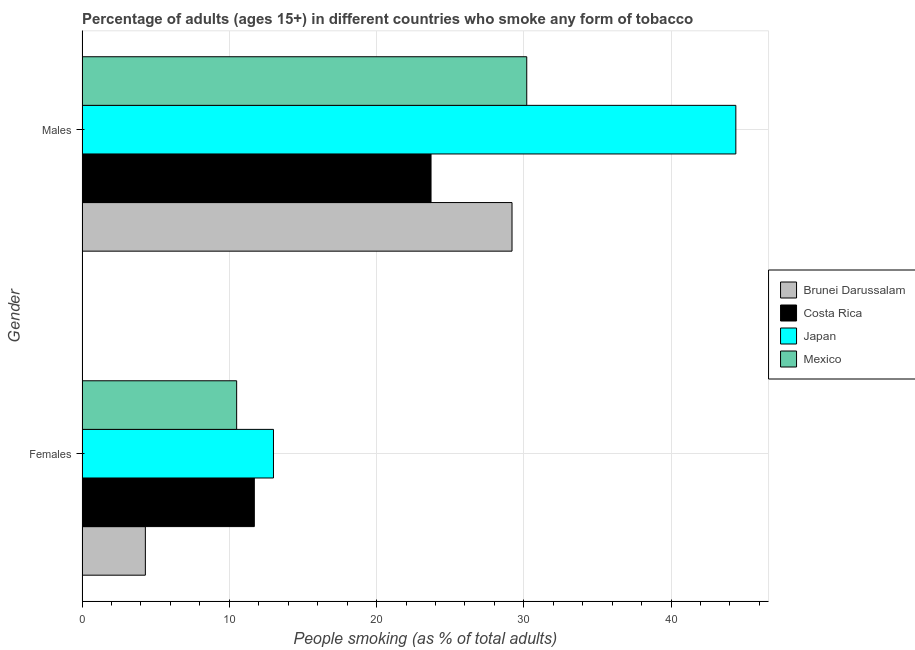How many different coloured bars are there?
Give a very brief answer. 4. Are the number of bars on each tick of the Y-axis equal?
Make the answer very short. Yes. How many bars are there on the 2nd tick from the top?
Offer a terse response. 4. What is the label of the 2nd group of bars from the top?
Your answer should be very brief. Females. Across all countries, what is the maximum percentage of males who smoke?
Provide a succinct answer. 44.4. In which country was the percentage of females who smoke minimum?
Your answer should be compact. Brunei Darussalam. What is the total percentage of females who smoke in the graph?
Offer a very short reply. 39.5. What is the difference between the percentage of females who smoke in Brunei Darussalam and the percentage of males who smoke in Mexico?
Give a very brief answer. -25.9. What is the average percentage of males who smoke per country?
Keep it short and to the point. 31.88. What is the difference between the percentage of females who smoke and percentage of males who smoke in Japan?
Provide a short and direct response. -31.4. In how many countries, is the percentage of females who smoke greater than 44 %?
Make the answer very short. 0. What is the ratio of the percentage of females who smoke in Brunei Darussalam to that in Japan?
Give a very brief answer. 0.33. In how many countries, is the percentage of males who smoke greater than the average percentage of males who smoke taken over all countries?
Give a very brief answer. 1. What does the 3rd bar from the top in Males represents?
Provide a succinct answer. Costa Rica. What does the 2nd bar from the bottom in Males represents?
Offer a terse response. Costa Rica. How many bars are there?
Offer a terse response. 8. How many countries are there in the graph?
Provide a short and direct response. 4. What is the difference between two consecutive major ticks on the X-axis?
Make the answer very short. 10. Does the graph contain grids?
Your response must be concise. Yes. Where does the legend appear in the graph?
Your answer should be compact. Center right. How are the legend labels stacked?
Provide a short and direct response. Vertical. What is the title of the graph?
Provide a short and direct response. Percentage of adults (ages 15+) in different countries who smoke any form of tobacco. What is the label or title of the X-axis?
Keep it short and to the point. People smoking (as % of total adults). What is the label or title of the Y-axis?
Make the answer very short. Gender. What is the People smoking (as % of total adults) of Brunei Darussalam in Females?
Provide a succinct answer. 4.3. What is the People smoking (as % of total adults) of Mexico in Females?
Your answer should be very brief. 10.5. What is the People smoking (as % of total adults) in Brunei Darussalam in Males?
Keep it short and to the point. 29.2. What is the People smoking (as % of total adults) in Costa Rica in Males?
Offer a very short reply. 23.7. What is the People smoking (as % of total adults) in Japan in Males?
Keep it short and to the point. 44.4. What is the People smoking (as % of total adults) of Mexico in Males?
Your response must be concise. 30.2. Across all Gender, what is the maximum People smoking (as % of total adults) of Brunei Darussalam?
Ensure brevity in your answer.  29.2. Across all Gender, what is the maximum People smoking (as % of total adults) of Costa Rica?
Offer a very short reply. 23.7. Across all Gender, what is the maximum People smoking (as % of total adults) of Japan?
Your response must be concise. 44.4. Across all Gender, what is the maximum People smoking (as % of total adults) in Mexico?
Keep it short and to the point. 30.2. Across all Gender, what is the minimum People smoking (as % of total adults) in Brunei Darussalam?
Keep it short and to the point. 4.3. What is the total People smoking (as % of total adults) of Brunei Darussalam in the graph?
Make the answer very short. 33.5. What is the total People smoking (as % of total adults) of Costa Rica in the graph?
Offer a very short reply. 35.4. What is the total People smoking (as % of total adults) of Japan in the graph?
Make the answer very short. 57.4. What is the total People smoking (as % of total adults) of Mexico in the graph?
Ensure brevity in your answer.  40.7. What is the difference between the People smoking (as % of total adults) of Brunei Darussalam in Females and that in Males?
Make the answer very short. -24.9. What is the difference between the People smoking (as % of total adults) of Japan in Females and that in Males?
Provide a succinct answer. -31.4. What is the difference between the People smoking (as % of total adults) of Mexico in Females and that in Males?
Provide a short and direct response. -19.7. What is the difference between the People smoking (as % of total adults) in Brunei Darussalam in Females and the People smoking (as % of total adults) in Costa Rica in Males?
Provide a succinct answer. -19.4. What is the difference between the People smoking (as % of total adults) in Brunei Darussalam in Females and the People smoking (as % of total adults) in Japan in Males?
Provide a succinct answer. -40.1. What is the difference between the People smoking (as % of total adults) in Brunei Darussalam in Females and the People smoking (as % of total adults) in Mexico in Males?
Keep it short and to the point. -25.9. What is the difference between the People smoking (as % of total adults) in Costa Rica in Females and the People smoking (as % of total adults) in Japan in Males?
Your response must be concise. -32.7. What is the difference between the People smoking (as % of total adults) of Costa Rica in Females and the People smoking (as % of total adults) of Mexico in Males?
Offer a very short reply. -18.5. What is the difference between the People smoking (as % of total adults) in Japan in Females and the People smoking (as % of total adults) in Mexico in Males?
Make the answer very short. -17.2. What is the average People smoking (as % of total adults) in Brunei Darussalam per Gender?
Provide a short and direct response. 16.75. What is the average People smoking (as % of total adults) of Costa Rica per Gender?
Keep it short and to the point. 17.7. What is the average People smoking (as % of total adults) of Japan per Gender?
Keep it short and to the point. 28.7. What is the average People smoking (as % of total adults) of Mexico per Gender?
Provide a succinct answer. 20.35. What is the difference between the People smoking (as % of total adults) of Brunei Darussalam and People smoking (as % of total adults) of Costa Rica in Females?
Ensure brevity in your answer.  -7.4. What is the difference between the People smoking (as % of total adults) in Japan and People smoking (as % of total adults) in Mexico in Females?
Give a very brief answer. 2.5. What is the difference between the People smoking (as % of total adults) in Brunei Darussalam and People smoking (as % of total adults) in Japan in Males?
Your response must be concise. -15.2. What is the difference between the People smoking (as % of total adults) in Costa Rica and People smoking (as % of total adults) in Japan in Males?
Ensure brevity in your answer.  -20.7. What is the difference between the People smoking (as % of total adults) in Costa Rica and People smoking (as % of total adults) in Mexico in Males?
Your answer should be compact. -6.5. What is the ratio of the People smoking (as % of total adults) in Brunei Darussalam in Females to that in Males?
Your answer should be compact. 0.15. What is the ratio of the People smoking (as % of total adults) in Costa Rica in Females to that in Males?
Make the answer very short. 0.49. What is the ratio of the People smoking (as % of total adults) in Japan in Females to that in Males?
Ensure brevity in your answer.  0.29. What is the ratio of the People smoking (as % of total adults) in Mexico in Females to that in Males?
Provide a short and direct response. 0.35. What is the difference between the highest and the second highest People smoking (as % of total adults) in Brunei Darussalam?
Offer a very short reply. 24.9. What is the difference between the highest and the second highest People smoking (as % of total adults) in Costa Rica?
Provide a succinct answer. 12. What is the difference between the highest and the second highest People smoking (as % of total adults) in Japan?
Make the answer very short. 31.4. What is the difference between the highest and the lowest People smoking (as % of total adults) of Brunei Darussalam?
Keep it short and to the point. 24.9. What is the difference between the highest and the lowest People smoking (as % of total adults) in Costa Rica?
Offer a terse response. 12. What is the difference between the highest and the lowest People smoking (as % of total adults) of Japan?
Your answer should be compact. 31.4. What is the difference between the highest and the lowest People smoking (as % of total adults) of Mexico?
Your answer should be compact. 19.7. 